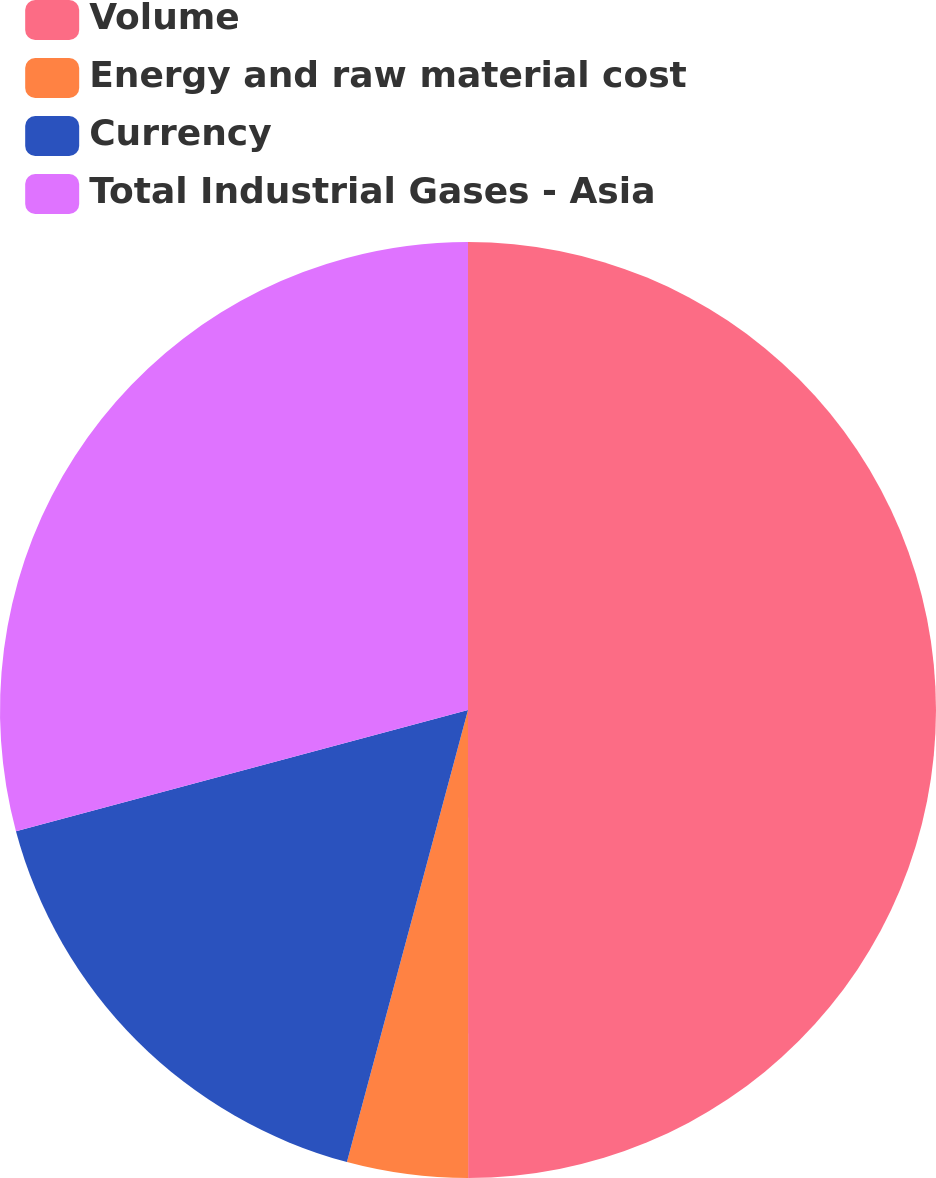Convert chart. <chart><loc_0><loc_0><loc_500><loc_500><pie_chart><fcel>Volume<fcel>Energy and raw material cost<fcel>Currency<fcel>Total Industrial Gases - Asia<nl><fcel>50.0%<fcel>4.17%<fcel>16.67%<fcel>29.17%<nl></chart> 